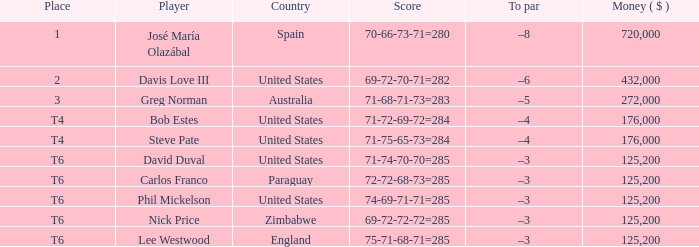Which spot has a peak value of -8? 1.0. 